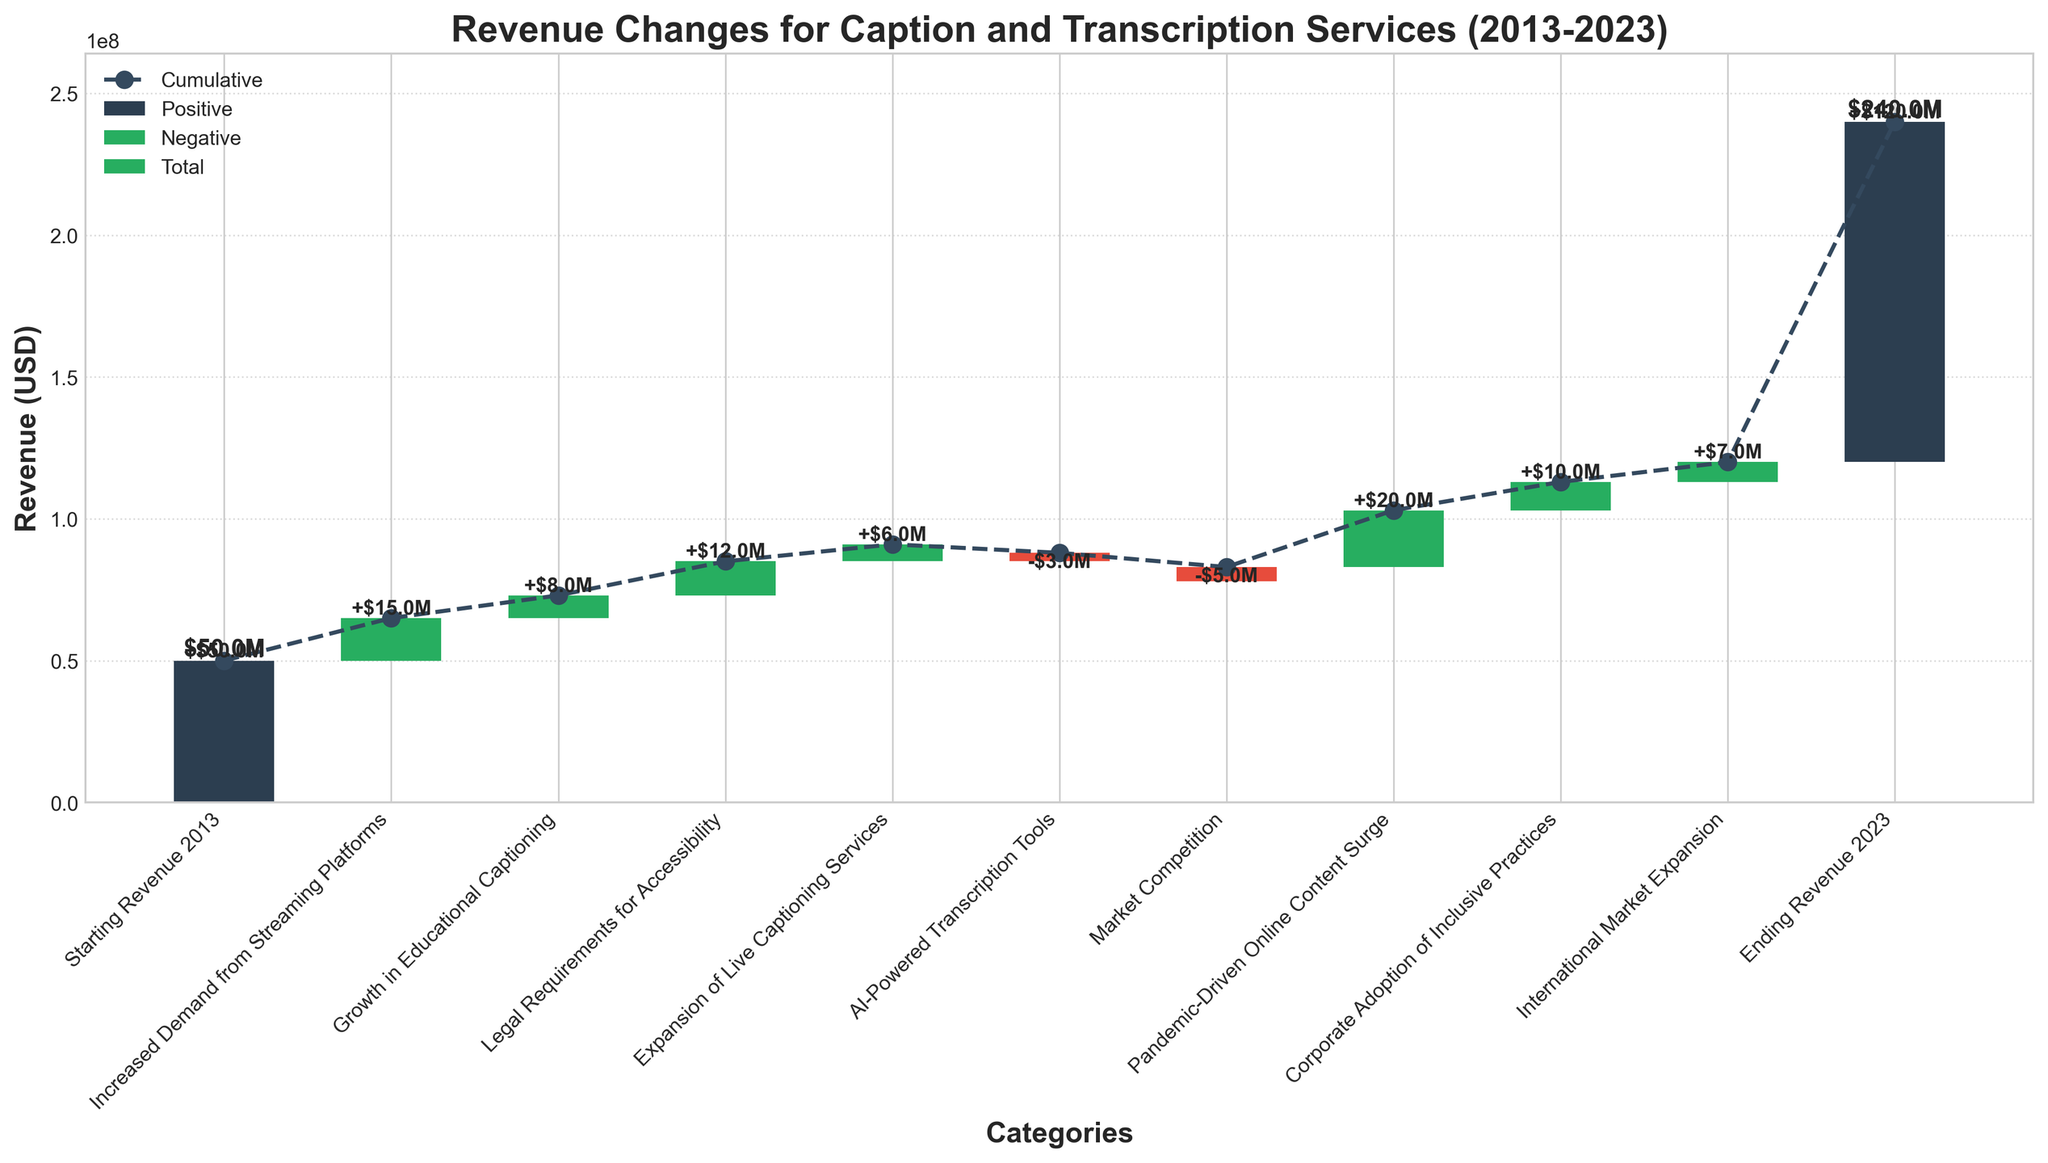What's the title of the figure? The title of the figure is located at the top and indicates the main topic it represents. In this case, it reads "Revenue Changes for Caption and Transcription Services (2013-2023)" which suggests that the figure shows how revenue has varied over the decade.
Answer: Revenue Changes for Caption and Transcription Services (2013-2023) What is the starting revenue in 2013? The starting revenue in 2013 is shown as the first bar in the chart. It is labeled as "Starting Revenue 2013" with the value at the bottom of the bar. According to the label, the value is $50,000,000.
Answer: $50,000,000 Which factor contributed the most to the revenue increase? To determine the largest contribution, compare the heights of all positive bars. The tallest bar among them is labeled "Pandemic-Driven Online Content Surge," with a value of $20,000,000.
Answer: Pandemic-Driven Online Content Surge How did AI-Powered Transcription Tools affect revenue? This requires identifying the portion labeled "AI-Powered Transcription Tools." It is a negative change, indicated by a red bar, with the value -$3,000,000.
Answer: Decreased by $3,000,000 What is the cumulative revenue at the end of 2023? The cumulative revenue at the end of 2023 is given by the total height of all the bars added sequentially till the end. The last bar labeled "Ending Revenue 2023," shows the cumulative value, which is $120,000,000.
Answer: $120,000,000 How does the ending revenue in 2023 compare to the starting revenue in 2013? Compare the values of the first and last bars. The starting revenue in 2013 is $50,000,000, and the ending revenue in 2023 is $120,000,000. Subtract the starting revenue from the ending revenue for the difference, $120,000,000 - $50,000,000 = $70,000,000.
Answer: Increased by $70,000,000 How much total revenue change is attributed to market competition and AI-powered transcription tools? Adding the values of the bars for "Market Competition" and "AI-Powered Transcription Tools" gives the total impact. Both are negative, so we have -$5,000,000 and -$3,000,000. Summing these, -$5,000,000 + -$3,000,000 = -$8,000,000.
Answer: -$8,000,000 What is the net effect of the “Increased Demand from Streaming Platforms” and “Growth in Educational Captioning”? Add the values of the two bars labeled "Increased Demand from Streaming Platforms" and "Growth in Educational Captioning". The values are $15,000,000 and $8,000,000, respectively. Thus, the net effect is $15,000,000 + $8,000,000 = $23,000,000.
Answer: $23,000,000 